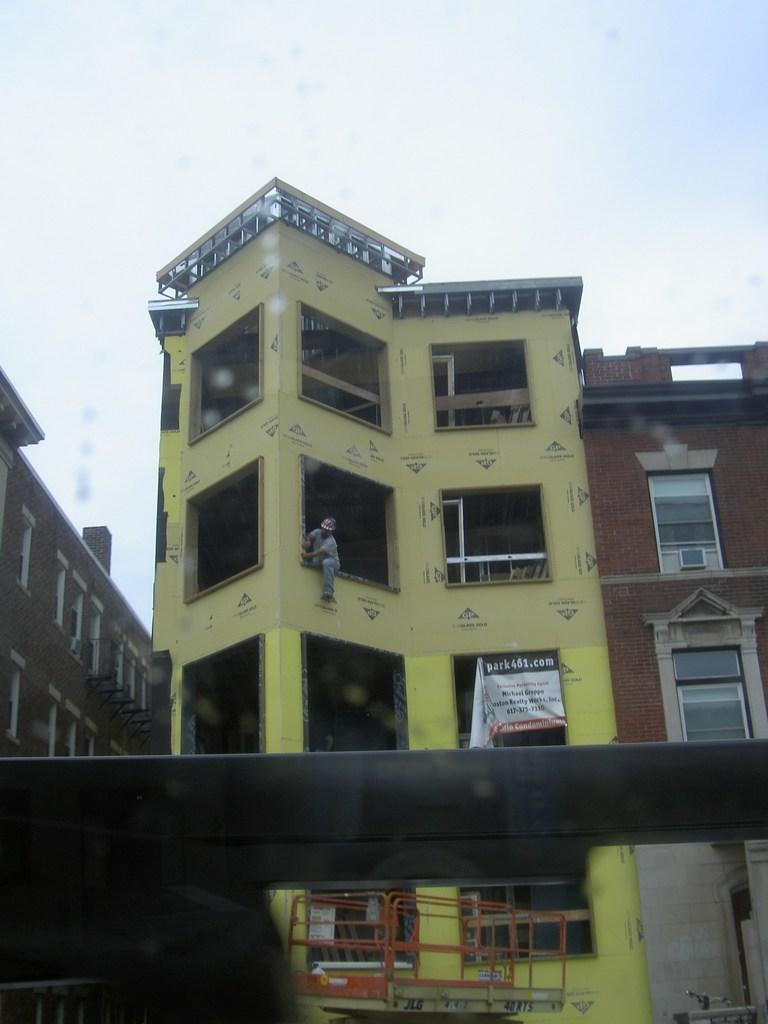Describe this image in one or two sentences. There are buildings. Here we can see a person and a banner. In the background there is sky. 